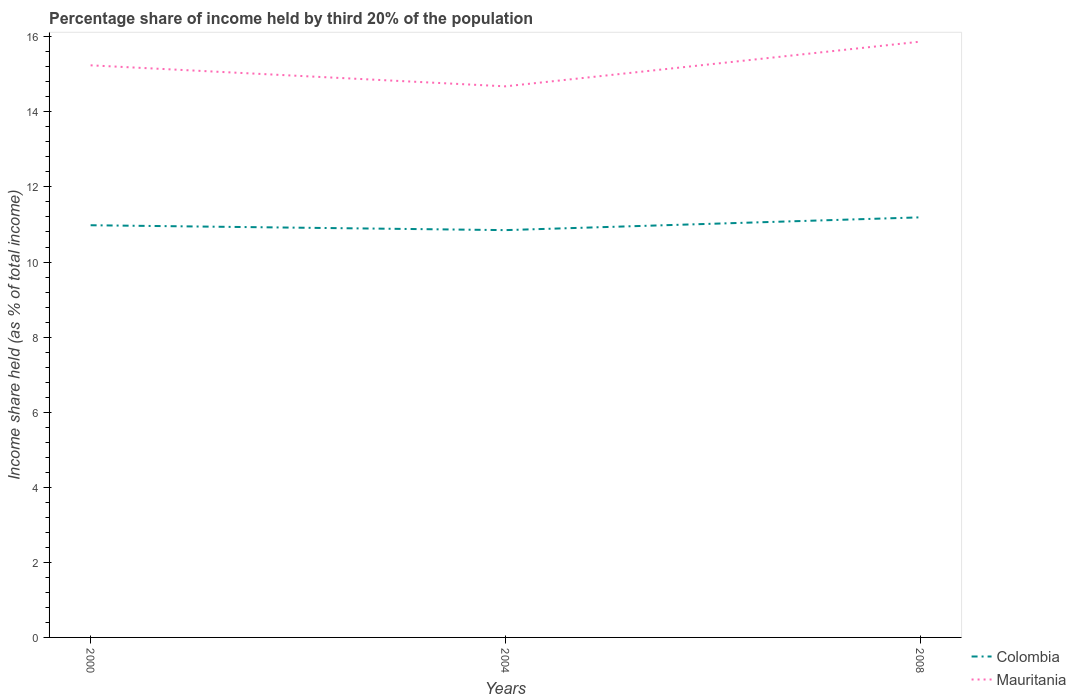How many different coloured lines are there?
Make the answer very short. 2. Is the number of lines equal to the number of legend labels?
Provide a short and direct response. Yes. Across all years, what is the maximum share of income held by third 20% of the population in Colombia?
Your answer should be compact. 10.85. In which year was the share of income held by third 20% of the population in Colombia maximum?
Give a very brief answer. 2004. What is the total share of income held by third 20% of the population in Colombia in the graph?
Offer a very short reply. -0.21. What is the difference between the highest and the second highest share of income held by third 20% of the population in Colombia?
Your answer should be very brief. 0.34. What is the difference between the highest and the lowest share of income held by third 20% of the population in Colombia?
Provide a succinct answer. 1. Is the share of income held by third 20% of the population in Mauritania strictly greater than the share of income held by third 20% of the population in Colombia over the years?
Offer a terse response. No. How many legend labels are there?
Provide a succinct answer. 2. What is the title of the graph?
Provide a short and direct response. Percentage share of income held by third 20% of the population. What is the label or title of the X-axis?
Make the answer very short. Years. What is the label or title of the Y-axis?
Your response must be concise. Income share held (as % of total income). What is the Income share held (as % of total income) in Colombia in 2000?
Your response must be concise. 10.98. What is the Income share held (as % of total income) of Mauritania in 2000?
Your response must be concise. 15.24. What is the Income share held (as % of total income) in Colombia in 2004?
Provide a succinct answer. 10.85. What is the Income share held (as % of total income) in Mauritania in 2004?
Ensure brevity in your answer.  14.68. What is the Income share held (as % of total income) of Colombia in 2008?
Make the answer very short. 11.19. What is the Income share held (as % of total income) in Mauritania in 2008?
Make the answer very short. 15.87. Across all years, what is the maximum Income share held (as % of total income) in Colombia?
Your answer should be very brief. 11.19. Across all years, what is the maximum Income share held (as % of total income) in Mauritania?
Offer a very short reply. 15.87. Across all years, what is the minimum Income share held (as % of total income) of Colombia?
Make the answer very short. 10.85. Across all years, what is the minimum Income share held (as % of total income) of Mauritania?
Give a very brief answer. 14.68. What is the total Income share held (as % of total income) of Colombia in the graph?
Offer a terse response. 33.02. What is the total Income share held (as % of total income) of Mauritania in the graph?
Offer a very short reply. 45.79. What is the difference between the Income share held (as % of total income) of Colombia in 2000 and that in 2004?
Your answer should be very brief. 0.13. What is the difference between the Income share held (as % of total income) of Mauritania in 2000 and that in 2004?
Offer a very short reply. 0.56. What is the difference between the Income share held (as % of total income) in Colombia in 2000 and that in 2008?
Offer a very short reply. -0.21. What is the difference between the Income share held (as % of total income) in Mauritania in 2000 and that in 2008?
Keep it short and to the point. -0.63. What is the difference between the Income share held (as % of total income) in Colombia in 2004 and that in 2008?
Provide a succinct answer. -0.34. What is the difference between the Income share held (as % of total income) of Mauritania in 2004 and that in 2008?
Your answer should be very brief. -1.19. What is the difference between the Income share held (as % of total income) of Colombia in 2000 and the Income share held (as % of total income) of Mauritania in 2004?
Provide a succinct answer. -3.7. What is the difference between the Income share held (as % of total income) in Colombia in 2000 and the Income share held (as % of total income) in Mauritania in 2008?
Your answer should be very brief. -4.89. What is the difference between the Income share held (as % of total income) of Colombia in 2004 and the Income share held (as % of total income) of Mauritania in 2008?
Offer a terse response. -5.02. What is the average Income share held (as % of total income) of Colombia per year?
Your answer should be very brief. 11.01. What is the average Income share held (as % of total income) of Mauritania per year?
Make the answer very short. 15.26. In the year 2000, what is the difference between the Income share held (as % of total income) of Colombia and Income share held (as % of total income) of Mauritania?
Ensure brevity in your answer.  -4.26. In the year 2004, what is the difference between the Income share held (as % of total income) in Colombia and Income share held (as % of total income) in Mauritania?
Your response must be concise. -3.83. In the year 2008, what is the difference between the Income share held (as % of total income) in Colombia and Income share held (as % of total income) in Mauritania?
Provide a short and direct response. -4.68. What is the ratio of the Income share held (as % of total income) in Colombia in 2000 to that in 2004?
Offer a very short reply. 1.01. What is the ratio of the Income share held (as % of total income) in Mauritania in 2000 to that in 2004?
Offer a very short reply. 1.04. What is the ratio of the Income share held (as % of total income) of Colombia in 2000 to that in 2008?
Keep it short and to the point. 0.98. What is the ratio of the Income share held (as % of total income) in Mauritania in 2000 to that in 2008?
Provide a succinct answer. 0.96. What is the ratio of the Income share held (as % of total income) of Colombia in 2004 to that in 2008?
Offer a terse response. 0.97. What is the ratio of the Income share held (as % of total income) of Mauritania in 2004 to that in 2008?
Ensure brevity in your answer.  0.93. What is the difference between the highest and the second highest Income share held (as % of total income) in Colombia?
Make the answer very short. 0.21. What is the difference between the highest and the second highest Income share held (as % of total income) in Mauritania?
Offer a terse response. 0.63. What is the difference between the highest and the lowest Income share held (as % of total income) in Colombia?
Your response must be concise. 0.34. What is the difference between the highest and the lowest Income share held (as % of total income) in Mauritania?
Keep it short and to the point. 1.19. 